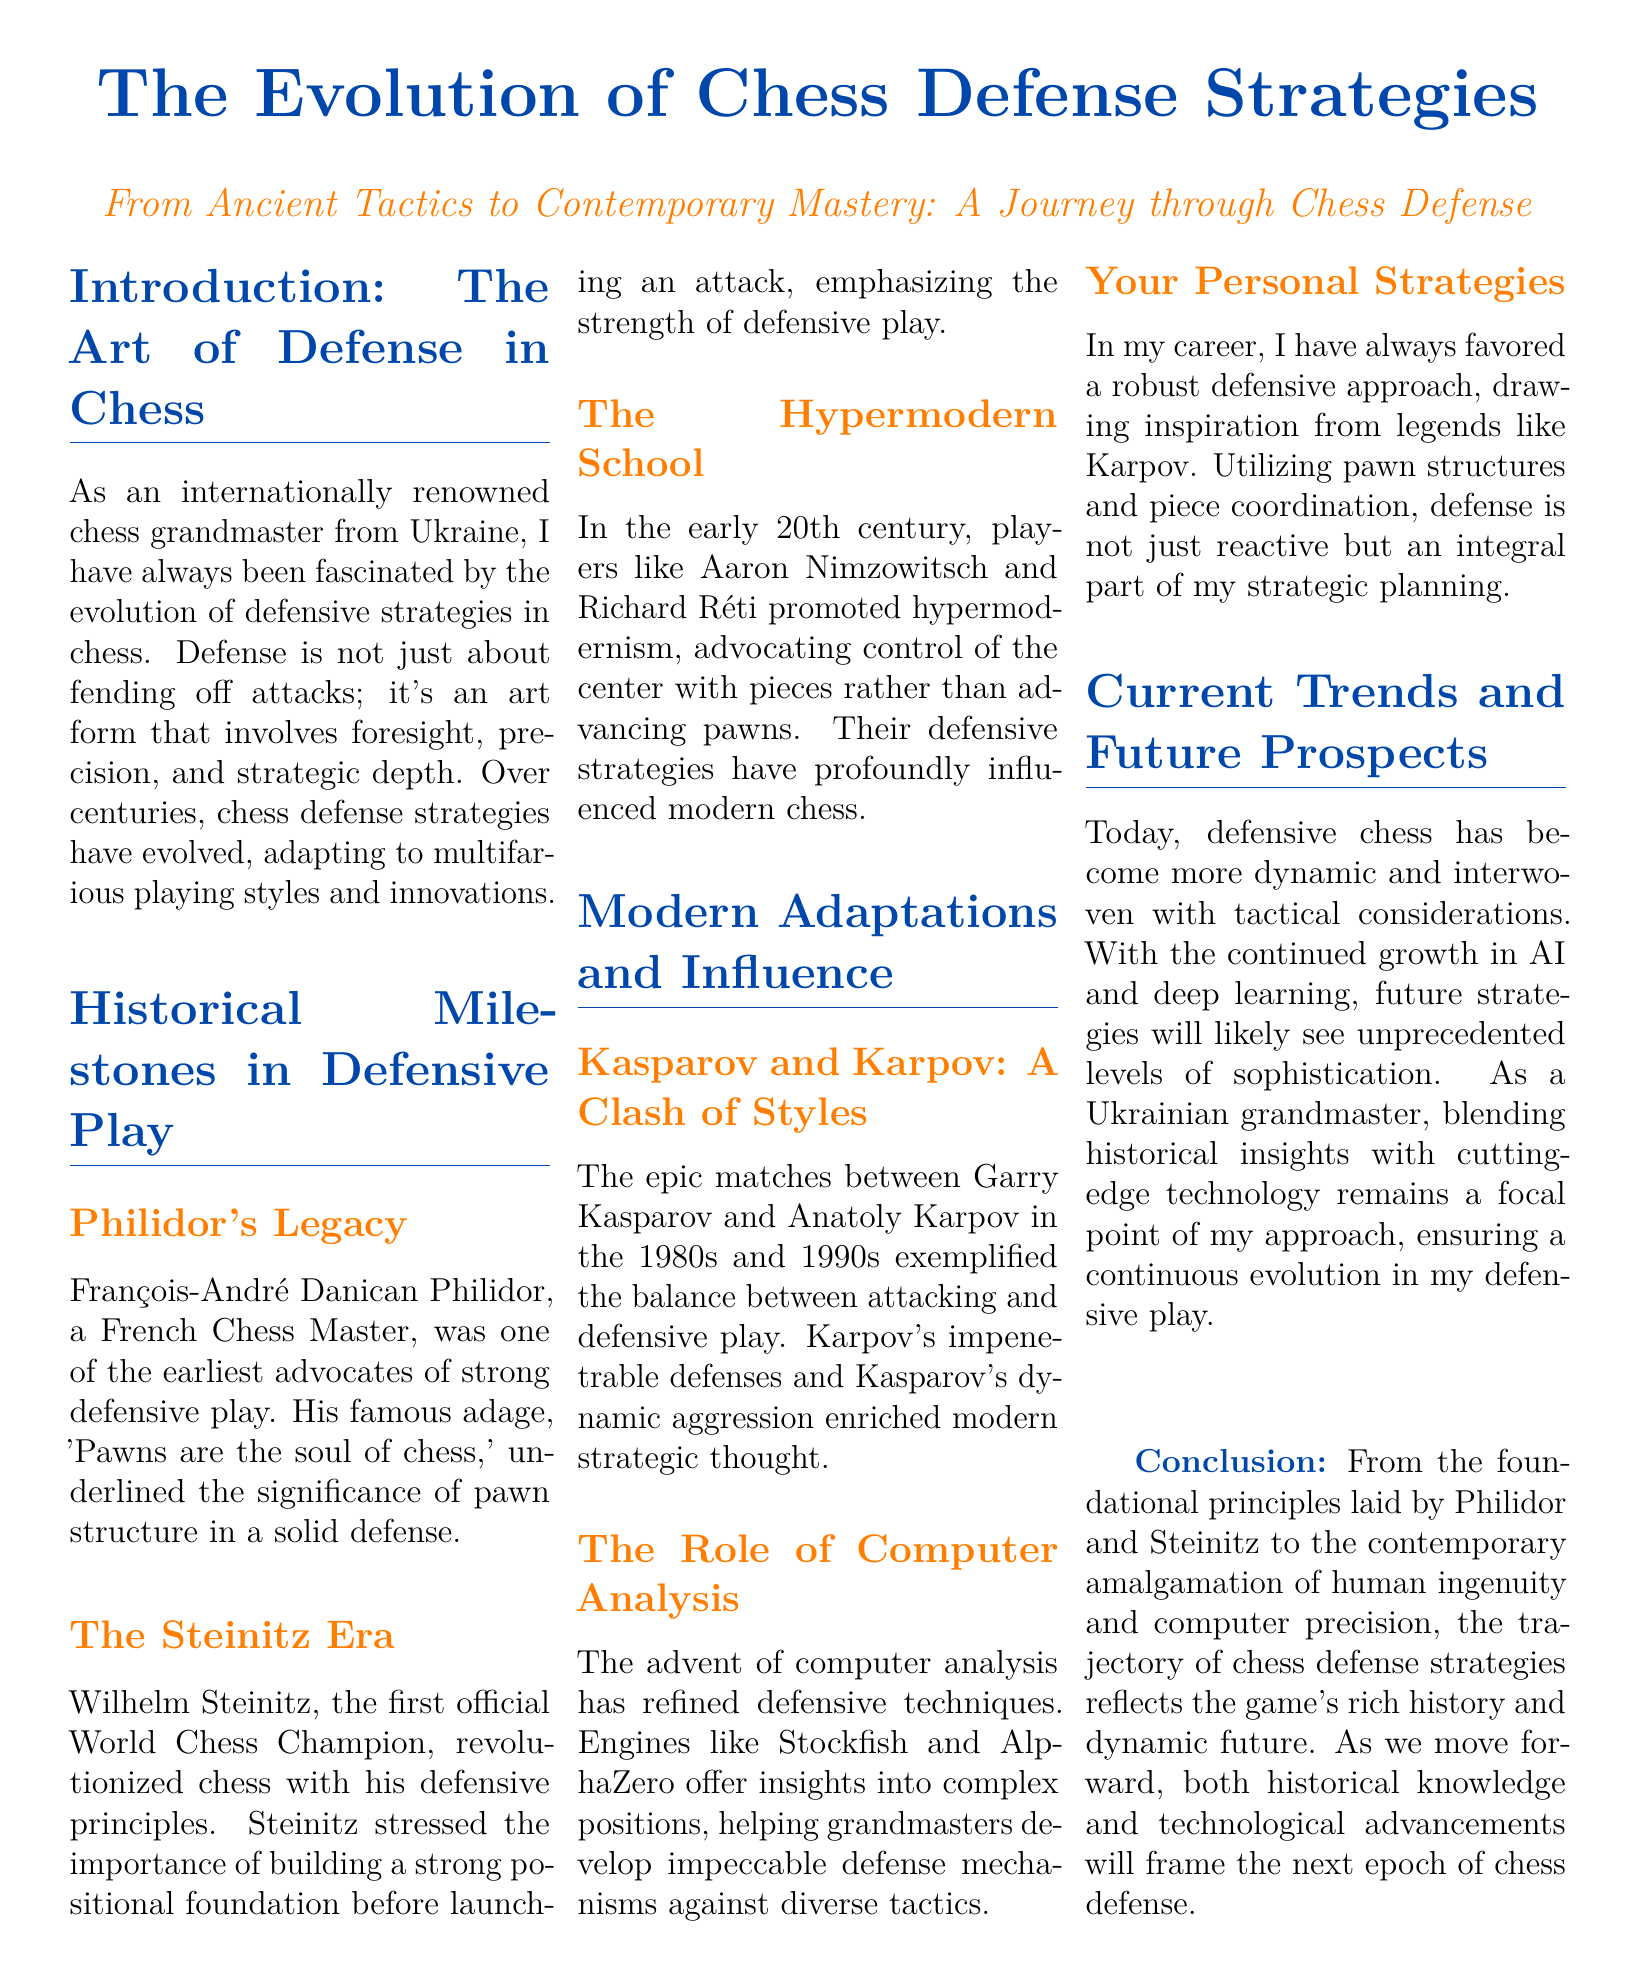What is the title of the document? The title of the document appears at the top of the layout, showcasing the main topic.
Answer: The Evolution of Chess Defense Strategies Who emphasized the importance of pawn structure? The document mentions a historical figure associated with the significance of pawn structure in defense.
Answer: François-André Danican Philidor Which chess champion is known for the first official title? The section discusses the first official World Chess Champion who revolutionized defensive play.
Answer: Wilhelm Steinitz What playing style did Nimzowitsch and Réti promote? This question focuses on a specific movement within chess defense strategies mentioned in the document.
Answer: Hypermodernism What do Kasparov and Karpov represent in chess history? The document highlights their matches to exemplify the balance in chess strategies.
Answer: A clash of styles Which technology is mentioned as refining defensive techniques? The document points to a technological advancement that has helped in analyzing chess positions.
Answer: Computer analysis What year range is associated with the matches between Kasparov and Karpov? The document specifies a decade when their notable matches occurred.
Answer: 1980s and 1990s What does the author favor in their personal strategies? The document reveals the author's preference which reflects their defensive approach.
Answer: Robust defensive approach 